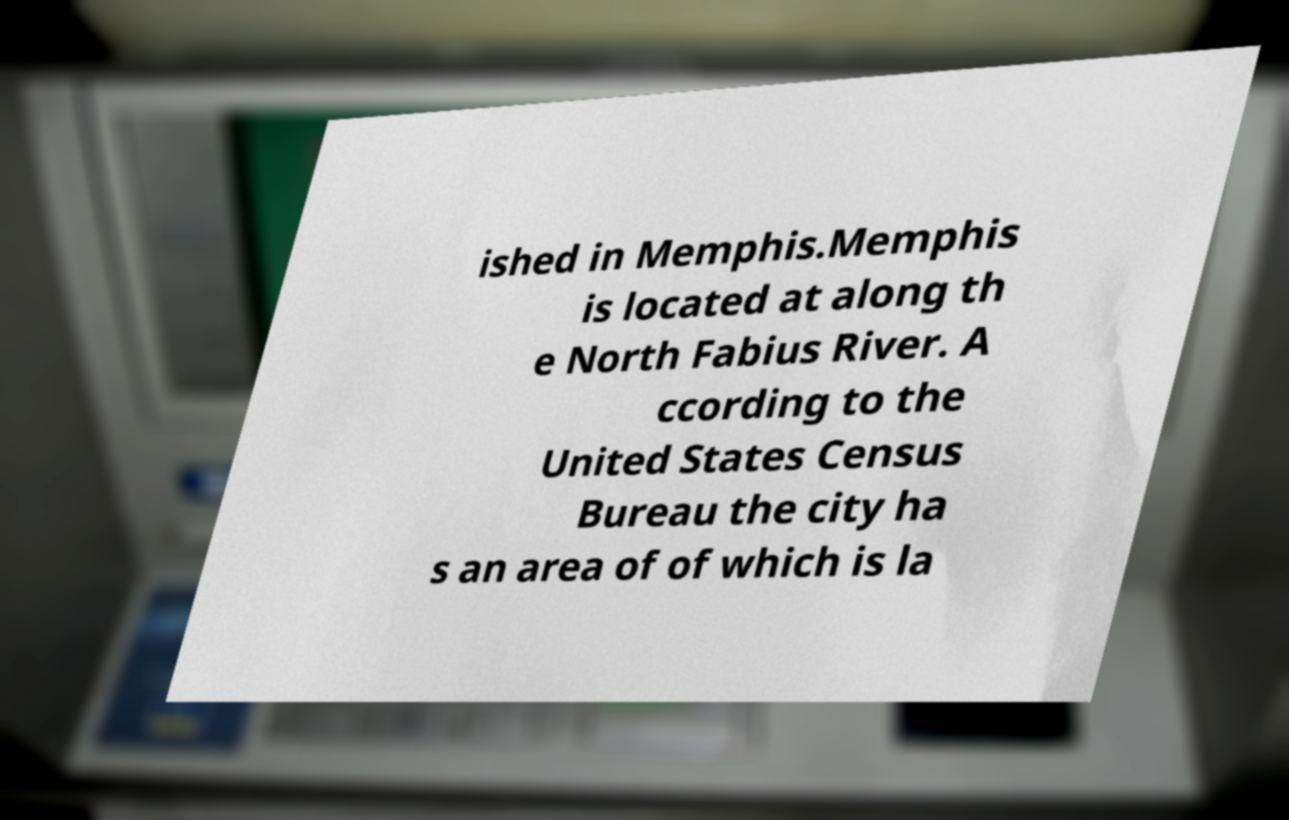There's text embedded in this image that I need extracted. Can you transcribe it verbatim? ished in Memphis.Memphis is located at along th e North Fabius River. A ccording to the United States Census Bureau the city ha s an area of of which is la 